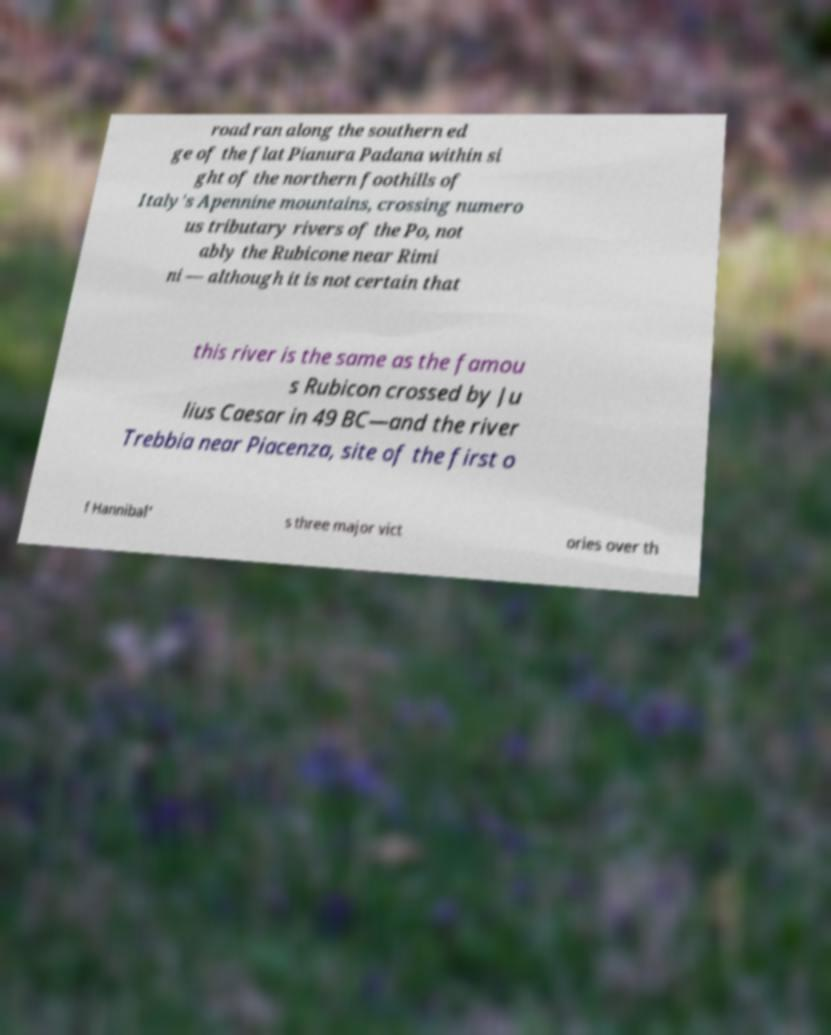Can you read and provide the text displayed in the image?This photo seems to have some interesting text. Can you extract and type it out for me? road ran along the southern ed ge of the flat Pianura Padana within si ght of the northern foothills of Italy's Apennine mountains, crossing numero us tributary rivers of the Po, not ably the Rubicone near Rimi ni — although it is not certain that this river is the same as the famou s Rubicon crossed by Ju lius Caesar in 49 BC—and the river Trebbia near Piacenza, site of the first o f Hannibal' s three major vict ories over th 